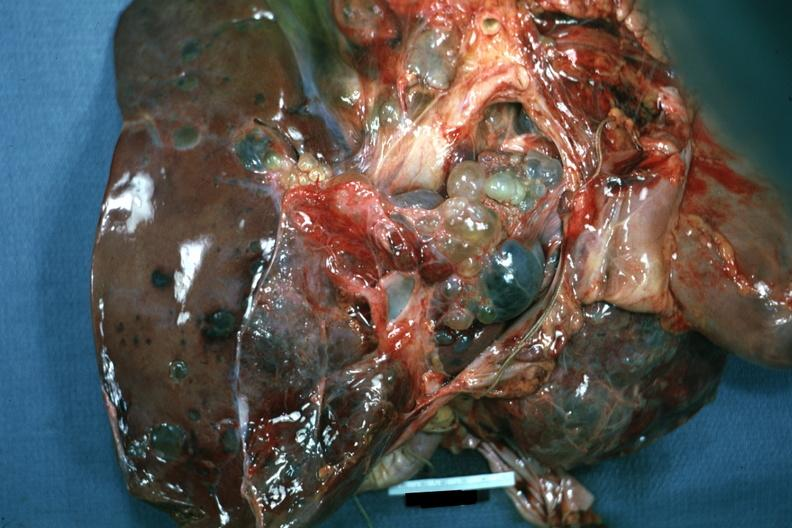s hepatobiliary present?
Answer the question using a single word or phrase. Yes 